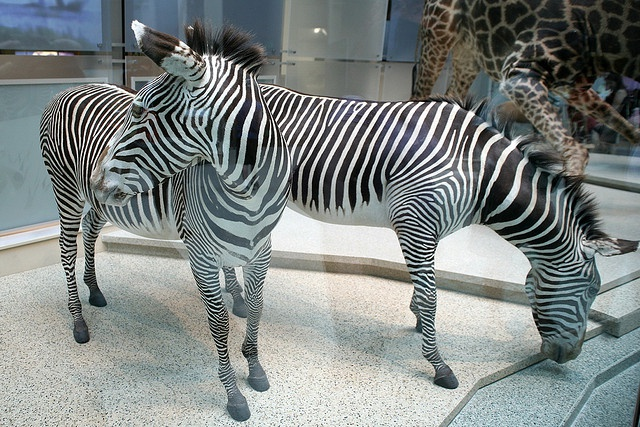Describe the objects in this image and their specific colors. I can see zebra in gray, black, darkgray, and lightgray tones, zebra in gray, black, darkgray, and white tones, and giraffe in gray, black, and darkgray tones in this image. 